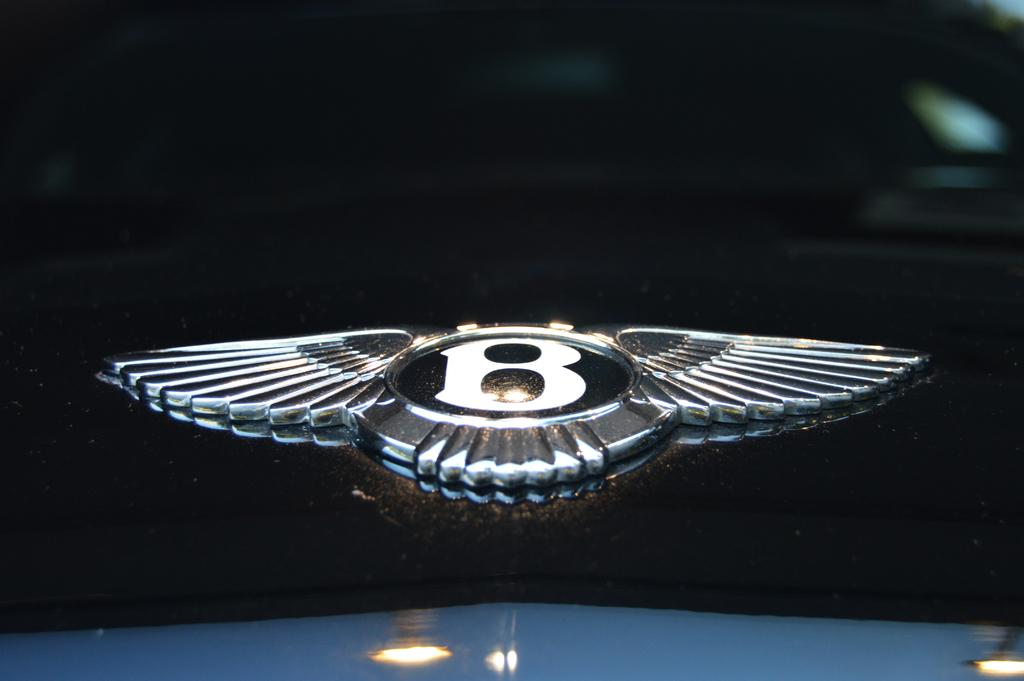What is located on the car bonnet in the image? There is an emblem on the car bonnet in the image. How many cakes are being served by the worm in the image? There is no worm or cakes present in the image; it only features a car bonnet with an emblem. 